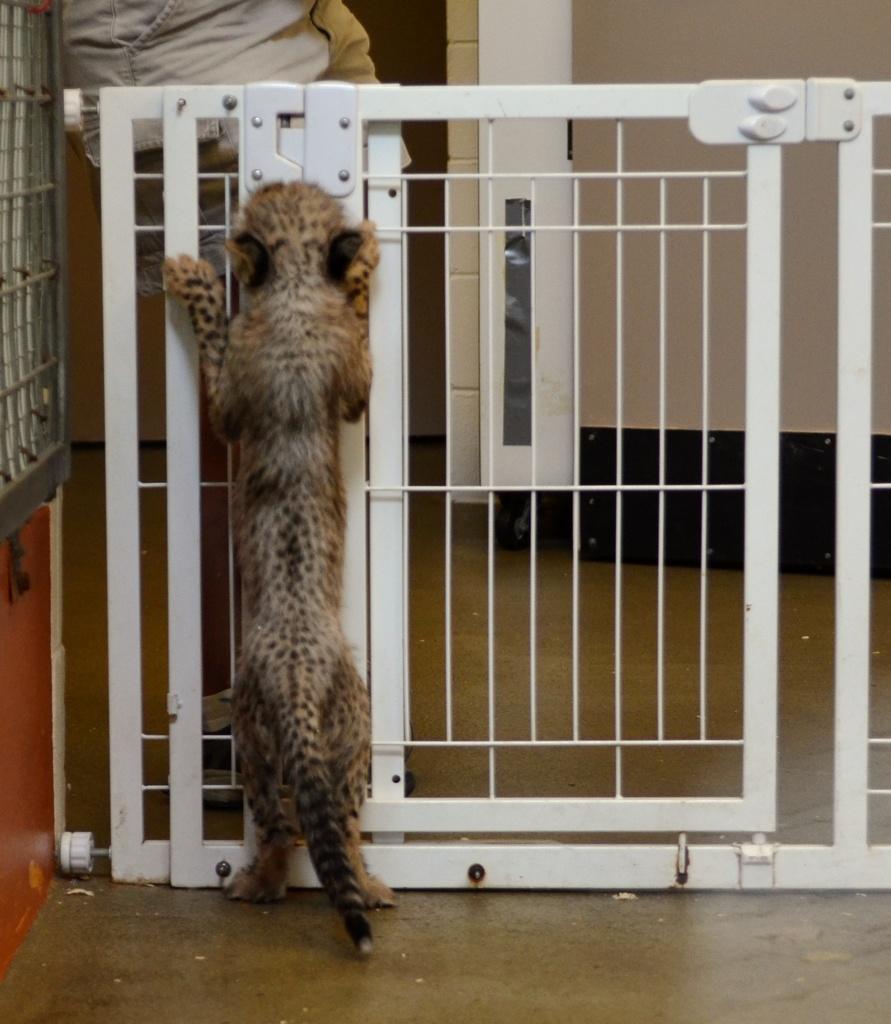Describe this image in one or two sentences. In this image we can see an animal near the grille and a person standing on the other side of the grille and wall in the background. 